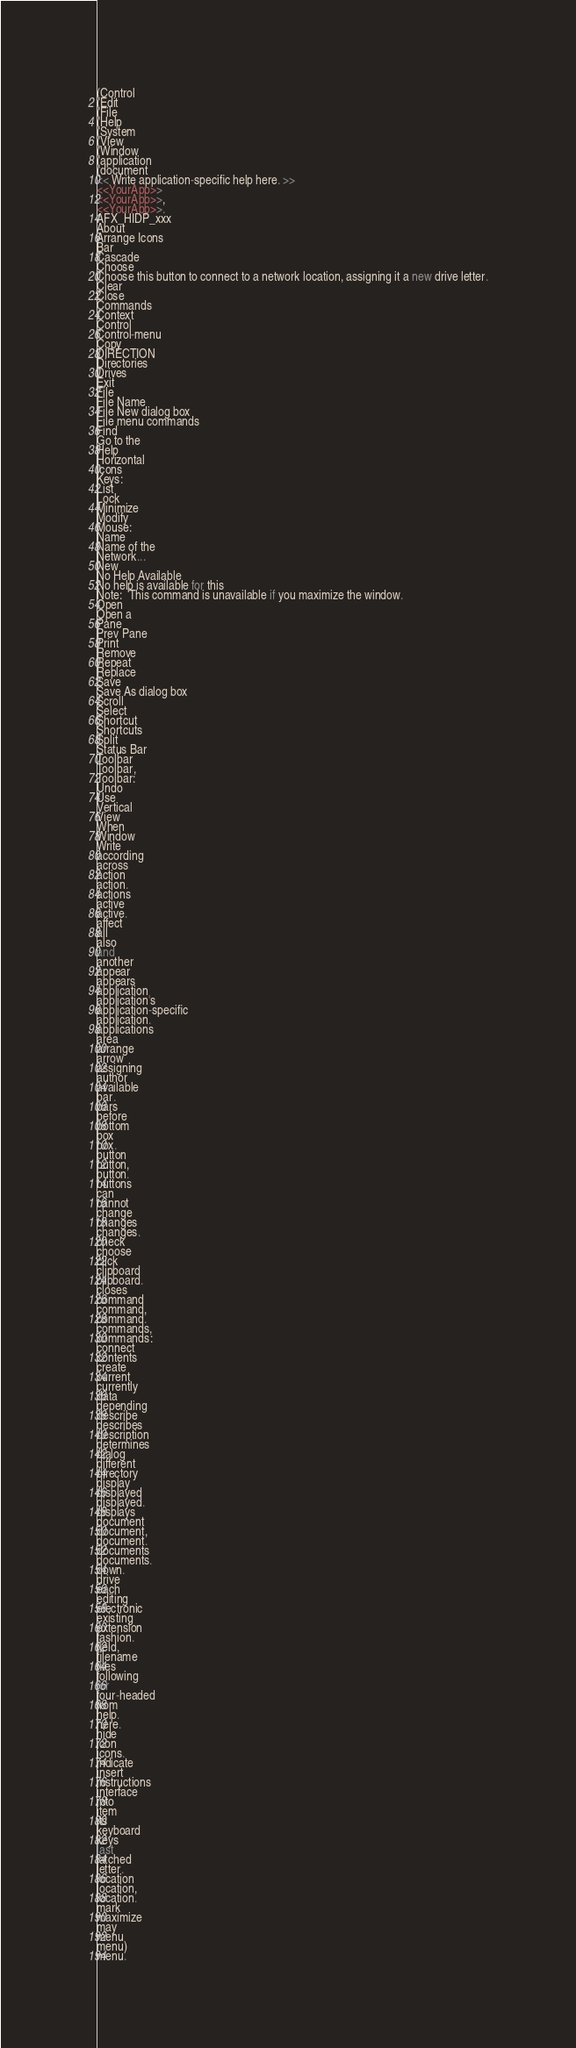<code> <loc_0><loc_0><loc_500><loc_500><_Perl_>(Control
(Edit
(File
(Help
(System
(View
(Window
(application
(document
<< Write application-specific help here. >>
<<YourApp>>
<<YourApp>>,
<<YourApp>>.
AFX_HIDP_xxx
About
Arrange Icons
Bar
Cascade
Choose
Choose this button to connect to a network location, assigning it a new drive letter.
Clear
Close
Commands
Context
Control
Control-menu
Copy
DIRECTION
Directories
Drives
Exit
File
File Name
File New dialog box
File menu commands
Find
Go to the
Help
Horizontal
Icons
Keys:
List
Lock
Minimize
Modify
Mouse:
Name
Name of the
Network...
New
No Help Available
No help is available for this
Note:  This command is unavailable if you maximize the window.
Open
Open a
Pane
Prev Pane
Print
Remove
Repeat
Replace
Save
Save As dialog box
Scroll
Select
Shortcut
Shortcuts
Split
Status Bar
Toolbar
Toolbar,
Toolbar:
Undo
Use
Vertical
View
When
Window
Write
according
across
action
action.
actions
active
active.
affect
all
also
and
another
appear
appears
application
application's
application-specific
application.
applications
area
arrange
arrow
assigning
author
available
bar.
bars
before
bottom
box
box.
button
button,
button.
buttons
can
cannot
change
changes
changes.
check
choose
click
clipboard
clipboard.
closes
command
command,
command.
commands,
commands:
connect
contents
create
current
currently
data
depending
describe
describes
description
determines
dialog
different
directory
display
displayed
displayed.
displays
document
document,
document.
documents
documents.
down.
drive
each
editing
electronic
existing
extension
fashion.
field,
filename
files
following
for
four-headed
from
help.
here.
hide
icon
icons.
indicate
insert
instructions
interface
into
item
its
keyboard
keys
last
latched
letter.
location
location,
location.
mark
maximize
may
menu
menu)
menu.</code> 